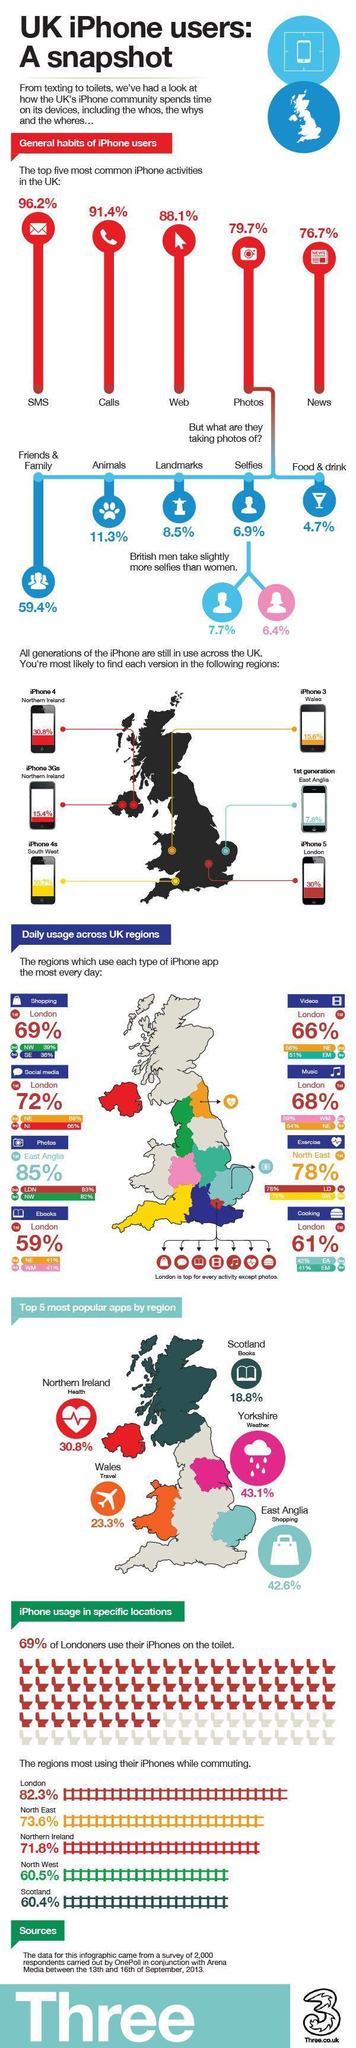What percentage of selfies were taken by men in iPhones in UK as per the survey in 2013?
Answer the question with a short phrase. 7.7% Which country in UK still use iPhone 3 series according to the survey in 2013? Wales What percentage of selfies were taken by women in iPhones in UK as per the survey in 2013?? 6.4% What percentage of people still use iPhone 4 in the Northern Ireland as per the survey in 2013? 30.8% What percentage of people still use first generation iPhones in East Anglia as per the survey in 2013? 7.8% Which country in UK still use iPhone 5 series according to the survey in 2013? London What percentage of iPhone users in UK spend their time in making calls as per the survey in 2013? 91.4% What percentage of iPhone users  in UK spend their time by taking photos according to the survey in 2013? 79.7% In which activity, majority of the iPhone users in UK spend their time as per the survey in 2013? SMS What percentage of iPhone users in North West London use iPhone app for shopping as per the survey in 2013? 39% 